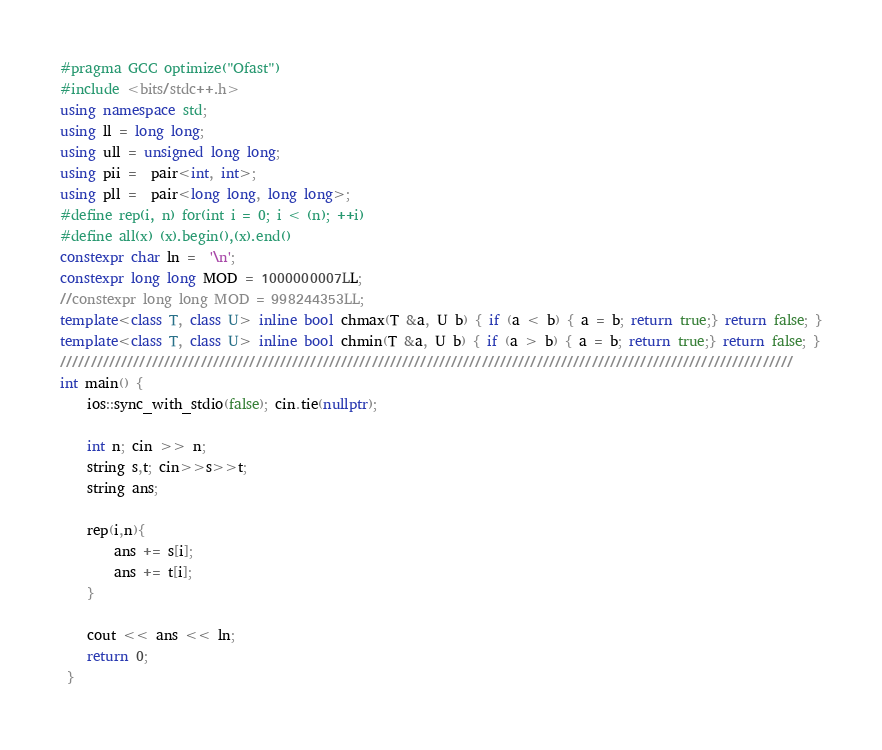<code> <loc_0><loc_0><loc_500><loc_500><_C++_>#pragma GCC optimize("Ofast")
#include <bits/stdc++.h>
using namespace std;
using ll = long long;
using ull = unsigned long long; 
using pii =  pair<int, int>;
using pll =  pair<long long, long long>;
#define rep(i, n) for(int i = 0; i < (n); ++i)
#define all(x) (x).begin(),(x).end()
constexpr char ln =  '\n';
constexpr long long MOD = 1000000007LL;
//constexpr long long MOD = 998244353LL;
template<class T, class U> inline bool chmax(T &a, U b) { if (a < b) { a = b; return true;} return false; }
template<class T, class U> inline bool chmin(T &a, U b) { if (a > b) { a = b; return true;} return false; }
////////////////////////////////////////////////////////////////////////////////////////////////////////////////////////
int main() {
    ios::sync_with_stdio(false); cin.tie(nullptr);
    
    int n; cin >> n;
    string s,t; cin>>s>>t;
    string ans;
    
    rep(i,n){
        ans += s[i];
        ans += t[i];
    } 

    cout << ans << ln;
    return 0;
 }</code> 